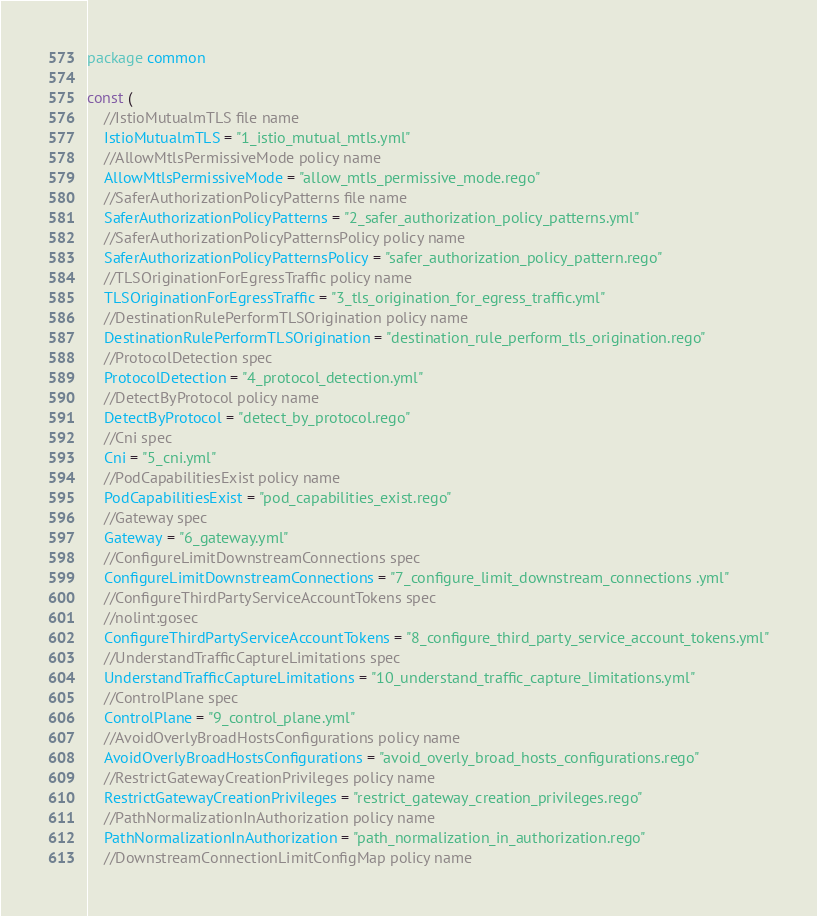<code> <loc_0><loc_0><loc_500><loc_500><_Go_>package common

const (
	//IstioMutualmTLS file name
	IstioMutualmTLS = "1_istio_mutual_mtls.yml"
	//AllowMtlsPermissiveMode policy name
	AllowMtlsPermissiveMode = "allow_mtls_permissive_mode.rego"
	//SaferAuthorizationPolicyPatterns file name
	SaferAuthorizationPolicyPatterns = "2_safer_authorization_policy_patterns.yml"
	//SaferAuthorizationPolicyPatternsPolicy policy name
	SaferAuthorizationPolicyPatternsPolicy = "safer_authorization_policy_pattern.rego"
	//TLSOriginationForEgressTraffic policy name
	TLSOriginationForEgressTraffic = "3_tls_origination_for_egress_traffic.yml"
	//DestinationRulePerformTLSOrigination policy name
	DestinationRulePerformTLSOrigination = "destination_rule_perform_tls_origination.rego"
	//ProtocolDetection spec
	ProtocolDetection = "4_protocol_detection.yml"
	//DetectByProtocol policy name
	DetectByProtocol = "detect_by_protocol.rego"
	//Cni spec
	Cni = "5_cni.yml"
	//PodCapabilitiesExist policy name
	PodCapabilitiesExist = "pod_capabilities_exist.rego"
	//Gateway spec
	Gateway = "6_gateway.yml"
	//ConfigureLimitDownstreamConnections spec
	ConfigureLimitDownstreamConnections = "7_configure_limit_downstream_connections .yml"
	//ConfigureThirdPartyServiceAccountTokens spec
	//nolint:gosec
	ConfigureThirdPartyServiceAccountTokens = "8_configure_third_party_service_account_tokens.yml"
	//UnderstandTrafficCaptureLimitations spec
	UnderstandTrafficCaptureLimitations = "10_understand_traffic_capture_limitations.yml"
	//ControlPlane spec
	ControlPlane = "9_control_plane.yml"
	//AvoidOverlyBroadHostsConfigurations policy name
	AvoidOverlyBroadHostsConfigurations = "avoid_overly_broad_hosts_configurations.rego"
	//RestrictGatewayCreationPrivileges policy name
	RestrictGatewayCreationPrivileges = "restrict_gateway_creation_privileges.rego"
	//PathNormalizationInAuthorization policy name
	PathNormalizationInAuthorization = "path_normalization_in_authorization.rego"
	//DownstreamConnectionLimitConfigMap policy name</code> 